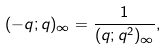<formula> <loc_0><loc_0><loc_500><loc_500>( - q ; q ) _ { \infty } = \frac { 1 } { ( q ; q ^ { 2 } ) _ { \infty } } ,</formula> 